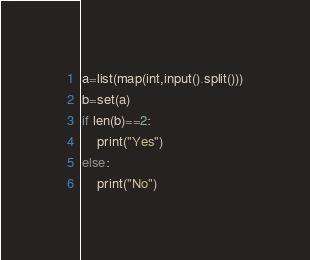Convert code to text. <code><loc_0><loc_0><loc_500><loc_500><_Python_>a=list(map(int,input().split()))
b=set(a)
if len(b)==2:
    print("Yes")
else:
    print("No")</code> 